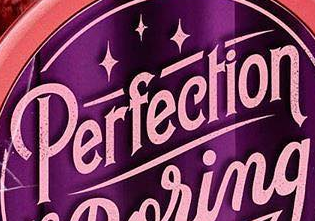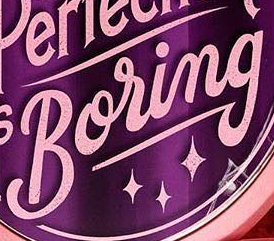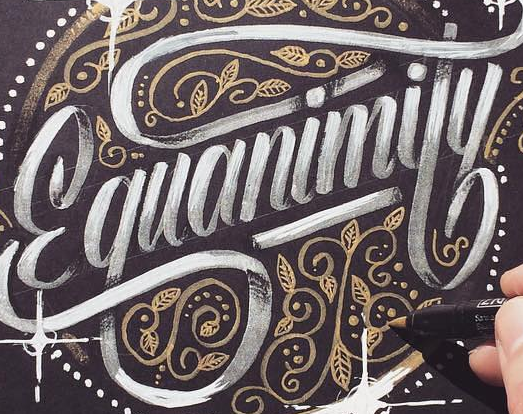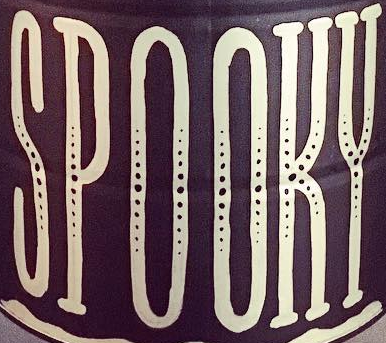What text is displayed in these images sequentially, separated by a semicolon? Perfection; Boring; Ɛquanimity; SPOOKY 